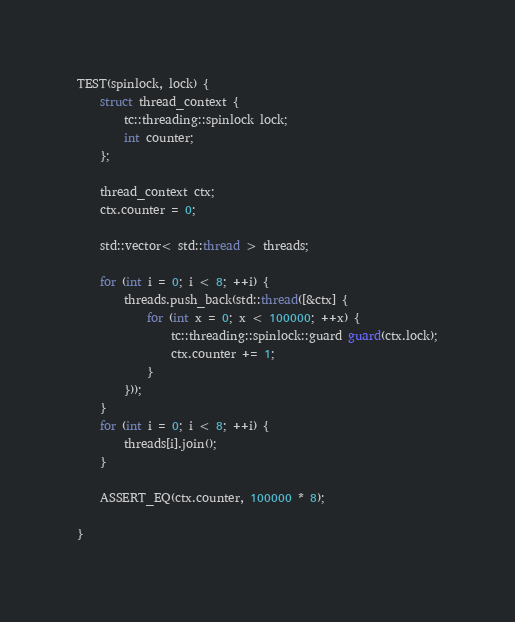<code> <loc_0><loc_0><loc_500><loc_500><_C++_>TEST(spinlock, lock) {
	struct thread_context {
		tc::threading::spinlock lock;
		int counter;
	};

	thread_context ctx;
	ctx.counter = 0;

	std::vector< std::thread > threads;

	for (int i = 0; i < 8; ++i) {
		threads.push_back(std::thread([&ctx] {
			for (int x = 0; x < 100000; ++x) {
				tc::threading::spinlock::guard guard(ctx.lock);
				ctx.counter += 1;
			}
		}));
	}
	for (int i = 0; i < 8; ++i) {
		threads[i].join();
	}

	ASSERT_EQ(ctx.counter, 100000 * 8);

}
</code> 